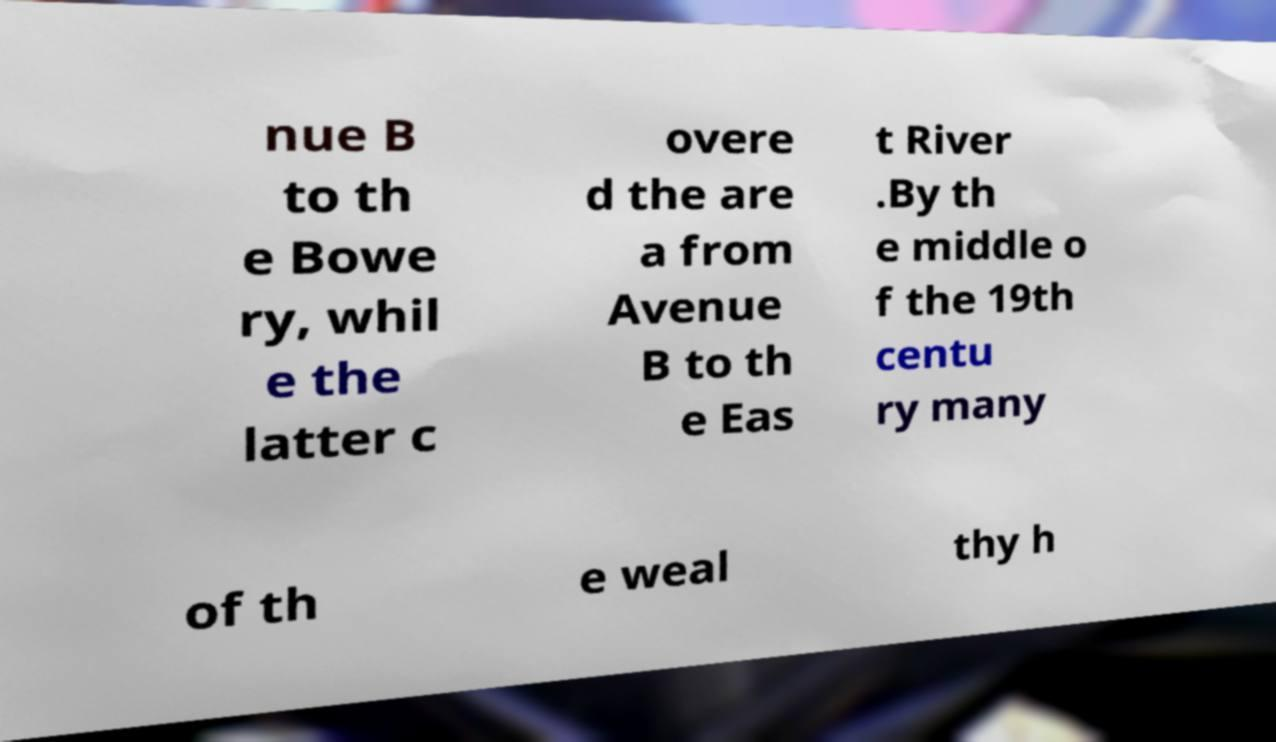Can you read and provide the text displayed in the image?This photo seems to have some interesting text. Can you extract and type it out for me? nue B to th e Bowe ry, whil e the latter c overe d the are a from Avenue B to th e Eas t River .By th e middle o f the 19th centu ry many of th e weal thy h 